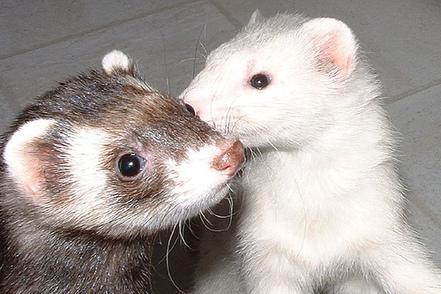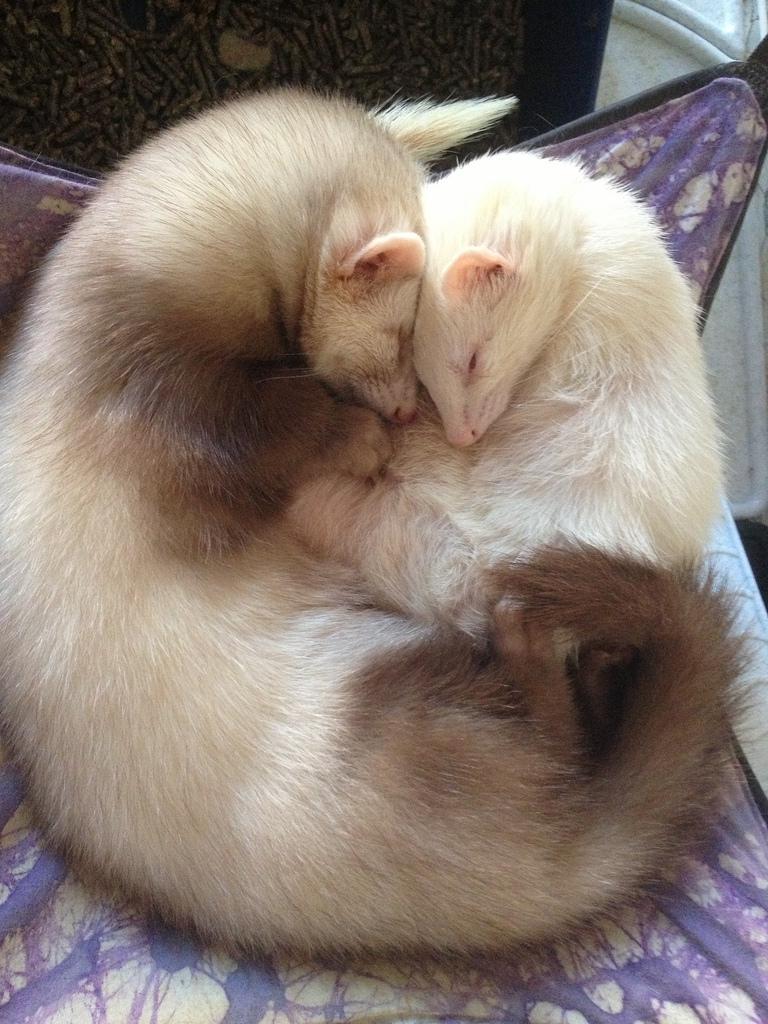The first image is the image on the left, the second image is the image on the right. Examine the images to the left and right. Is the description "In one image, a little animal is facing forward with its mouth wide open and tongue showing, while a second image shows two similar animals in different colors." accurate? Answer yes or no. No. The first image is the image on the left, the second image is the image on the right. Assess this claim about the two images: "A pair of ferrets are held side-by-side in a pair of human hands.". Correct or not? Answer yes or no. No. 